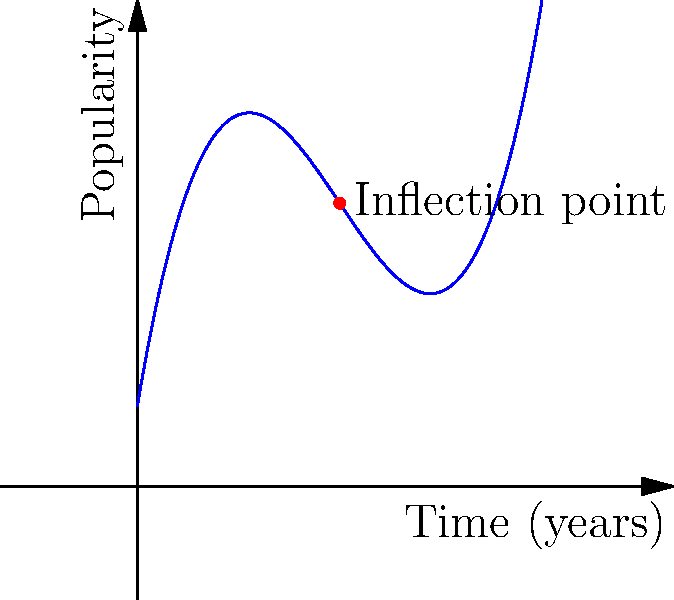As a crossword enthusiast tracking theme popularity, you've plotted the data for a particular theme over 10 years. The curve is represented by the function $f(x) = 0.1x^3 - 1.5x^2 + 6x + 2$, where $x$ is time in years and $f(x)$ is the theme's popularity. Find the inflection point(s) of this curve, which could indicate a significant shift in the theme's popularity trend. To find the inflection point(s), we need to follow these steps:

1) The inflection point occurs where the second derivative of the function equals zero or doesn't exist.

2) First, let's find the first derivative:
   $f'(x) = 0.3x^2 - 3x + 6$

3) Now, let's find the second derivative:
   $f''(x) = 0.6x - 3$

4) Set the second derivative equal to zero and solve for x:
   $0.6x - 3 = 0$
   $0.6x = 3$
   $x = 5$

5) We need to verify that the second derivative actually changes sign at this point. We can check the values just before and after x = 5:
   At x = 4.9: $f''(4.9) = 0.6(4.9) - 3 = -0.06$ (negative)
   At x = 5.1: $f''(5.1) = 0.6(5.1) - 3 = 0.06$ (positive)

6) The second derivative does change sign at x = 5, confirming this is an inflection point.

7) To find the y-coordinate of the inflection point, we substitute x = 5 into the original function:
   $f(5) = 0.1(5^3) - 1.5(5^2) + 6(5) + 2 = 12.5$

Therefore, the inflection point is at (5, 12.5).
Answer: (5, 12.5) 